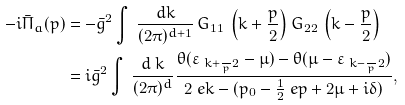<formula> <loc_0><loc_0><loc_500><loc_500>- i \bar { \Pi } _ { a } ( p ) & = - \bar { g } ^ { 2 } \int \, \frac { d k } { ( 2 \pi ) ^ { d + 1 } } \, G _ { 1 1 } \, \left ( k + \frac { p } { 2 } \right ) G _ { 2 2 } \, \left ( k - \frac { p } { 2 } \right ) \\ & = i \bar { g } ^ { 2 } \int \, \frac { d \ k } { ( 2 \pi ) ^ { d } } \frac { \theta ( \varepsilon _ { \ k + \frac { \ } { p } 2 } - \mu ) - \theta ( \mu - \varepsilon _ { \ k - \frac { \ } { p } 2 } ) } { 2 \ e k - ( p _ { 0 } - \frac { 1 } { 2 } \ e p + 2 \mu + i \delta ) } ,</formula> 